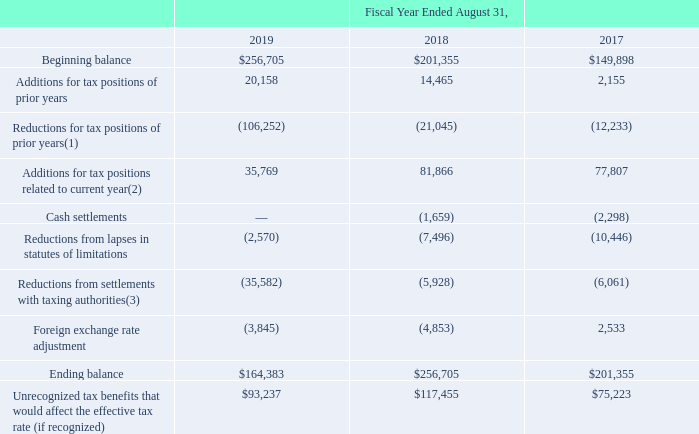Unrecognized Tax Benefits
Reconciliation of the unrecognized tax benefits is summarized below (in thousands):
(1) The reductions for tax positions of prior years for the fiscal year ended August 31, 2019 are primarily related to a non-U.S. taxing authority ruling related to certain non-U.S. net operating loss carry forwards, offset with a valuation allowance and the impacts of the Tax Act.
(2) The additions for the fiscal years ended August 31, 2019 and 2018 are primarily related to the impacts of the Tax Act and taxation of certain intercompany transactions. The additions for the fiscal year ended August 31, 2017 are primarily related to certain non-U.S. net operating loss carry forwards, previously offset with a valuation allowance, that can no longer be recognized due to an internal restructuring.
(3) The reductions from settlements with taxing authorities for the fiscal year ended August 31, 2019 are primarily related to the settlement of a U.S. audit.
The Company recognizes interest and penalties related to unrecognized tax benefits in income tax expense. The Company’s accrued interest and penalties were approximately $18.9 million and $20.4 million as of August 31, 2019 and 2018, respectively. The Company recognized interest and penalties of approximately $(1.5) million, $(6.7) million and $5.2 million during the fiscal years ended August 31, 2019, 2018 and 2017, respectively.
It is reasonably possible that the August 31, 2019 unrecognized tax benefits could decrease during the next 12 months by $5.8 million, primarily related to a state settlement.
The Company is no longer subject to U.S. federal tax examinations for fiscal years before August 31, 2015. In major non-U.S. and state jurisdictions, the Company is no longer subject to income tax examinations for fiscal years before August 31, 2009.
The Internal Revenue Service (“IRS”) completed its field examination of the Company’s tax returns for fiscal years 2009 through 2011 and issued a Revenue Agent’s Report (“RAR”) on May 27, 2015, which was updated on June 22, 2016. The IRS completed its field examination of the Company’s tax returns for fiscal years 2012 through 2014 and issued an RAR on April 19, 2017. The proposed adjustments in the RAR from both examination periods relate primarily to U.S. taxation of certain intercompany transactions. On May 8, 2019, the tax return audits for fiscal years 2009 through 2014 were effectively settled when the Company agreed to the IRS Office of Appeals’ Form 870-AD (Offer to Waive Restrictions on Assessment and Collection of Tax Deficiency and to Accept Overassessment) adjustments, which were substantially lower than the initial RAR proposed adjustments. The settlement did not have a material effect on the Company’s financial position, results of operations, or cash flows and no additional tax liabilities were recorded.
What were the reductions for tax positions  primarily related to? A non-u.s. taxing authority ruling related to certain non-u.s. net operating loss carry forwards, offset with a valuation allowance and the impacts of the tax act. What years does the table provide data for the Reconciliation of the unrecognized tax benefits? 2019, 2018, 2017. What were the additions for tax positions of prior years in 2019?
Answer scale should be: thousand. 20,158. What was the change in Additions for tax positions related to current year between 2018 and 2019?
Answer scale should be: thousand. 35,769-81,866
Answer: -46097. How many years did the beginning balance exceed $200,000 thousand? 2019##2018
Answer: 2. What was the percentage change in the ending balance between 2017 and 2018?
Answer scale should be: percent. ($256,705-$201,355)/$201,355
Answer: 27.49. 